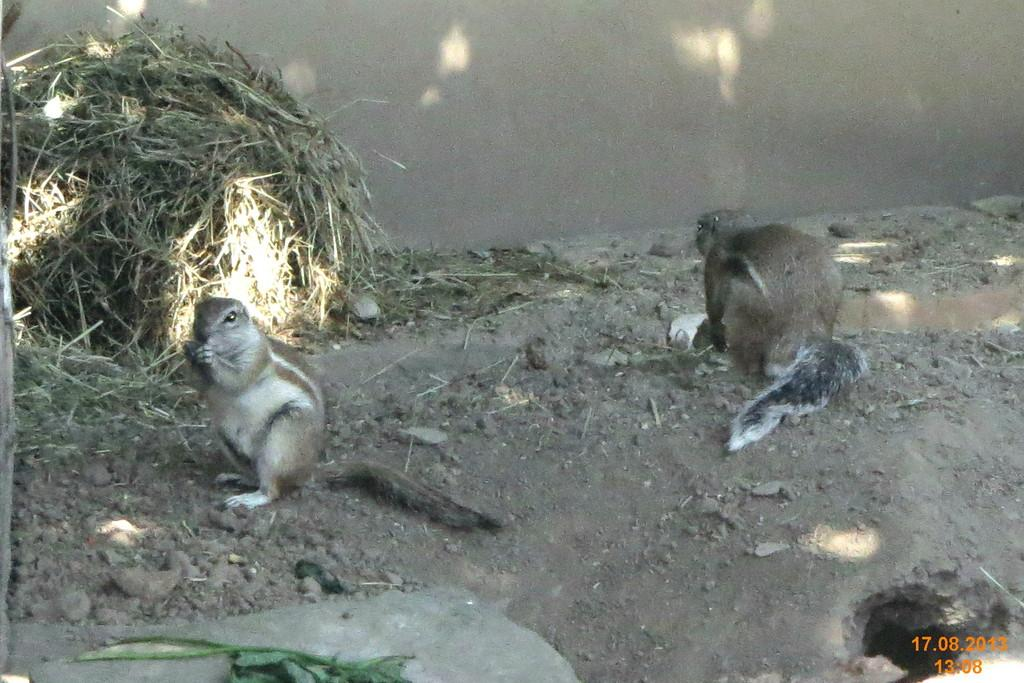What type of animals can be seen in the image? There are squirrels in the image. What is located at the bottom of the image? There is a rock at the bottom of the image. What can be seen on the right side of the image? There is a burrow on the right side of the image. What type of vegetation is visible in the background of the image? There is grass in the background of the image. What type of structure is visible in the background of the image? There is a wall in the background of the image. What type of leather material can be seen on the squirrels in the image? There is no leather material present on the squirrels in the image; they are animals with fur. 